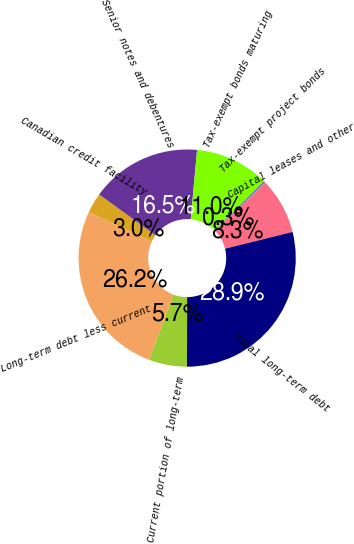<chart> <loc_0><loc_0><loc_500><loc_500><pie_chart><fcel>Canadian credit facility<fcel>Senior notes and debentures<fcel>Tax-exempt bonds maturing<fcel>Tax-exempt project bonds<fcel>Capital leases and other<fcel>Total long-term debt<fcel>Current portion of long-term<fcel>Long-term debt less current<nl><fcel>3.01%<fcel>16.5%<fcel>10.99%<fcel>0.35%<fcel>8.33%<fcel>28.9%<fcel>5.67%<fcel>26.25%<nl></chart> 